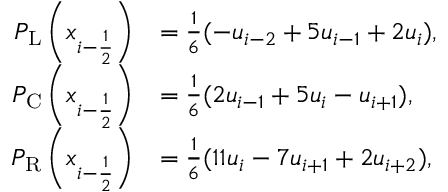Convert formula to latex. <formula><loc_0><loc_0><loc_500><loc_500>\begin{array} { r l } { P _ { L } \left ( x _ { i - { { \frac { 1 } { 2 } } } } \right ) } & { = \frac { 1 } { 6 } ( - u _ { i - 2 } + 5 u _ { i - 1 } + 2 u _ { i } ) , } \\ { P _ { C } \left ( x _ { i - { { \frac { 1 } { 2 } } } } \right ) } & { = \frac { 1 } { 6 } ( 2 u _ { i - 1 } + 5 u _ { i } - u _ { i + 1 } ) , } \\ { P _ { R } \left ( x _ { i - { { \frac { 1 } { 2 } } } } \right ) } & { = \frac { 1 } { 6 } ( 1 1 u _ { i } - 7 u _ { i + 1 } + 2 u _ { i + 2 } ) , } \end{array}</formula> 